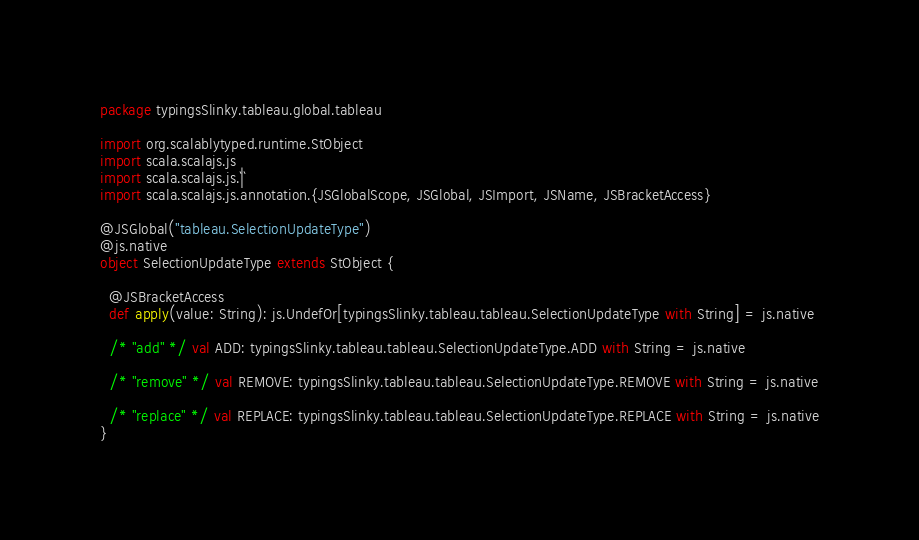<code> <loc_0><loc_0><loc_500><loc_500><_Scala_>package typingsSlinky.tableau.global.tableau

import org.scalablytyped.runtime.StObject
import scala.scalajs.js
import scala.scalajs.js.`|`
import scala.scalajs.js.annotation.{JSGlobalScope, JSGlobal, JSImport, JSName, JSBracketAccess}

@JSGlobal("tableau.SelectionUpdateType")
@js.native
object SelectionUpdateType extends StObject {
  
  @JSBracketAccess
  def apply(value: String): js.UndefOr[typingsSlinky.tableau.tableau.SelectionUpdateType with String] = js.native
  
  /* "add" */ val ADD: typingsSlinky.tableau.tableau.SelectionUpdateType.ADD with String = js.native
  
  /* "remove" */ val REMOVE: typingsSlinky.tableau.tableau.SelectionUpdateType.REMOVE with String = js.native
  
  /* "replace" */ val REPLACE: typingsSlinky.tableau.tableau.SelectionUpdateType.REPLACE with String = js.native
}
</code> 